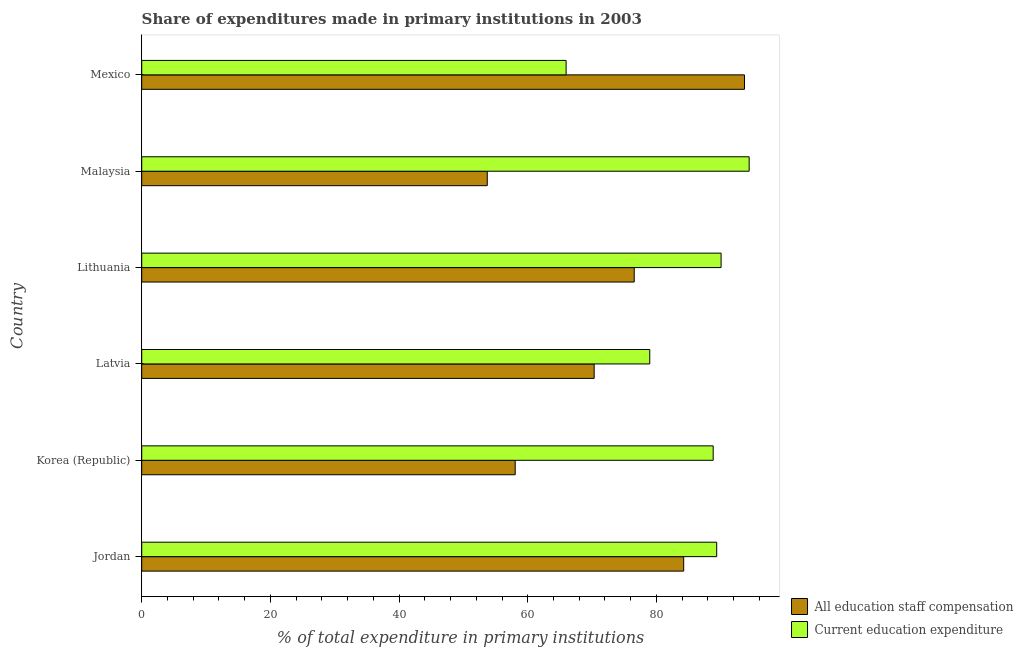How many different coloured bars are there?
Your answer should be very brief. 2. How many groups of bars are there?
Your response must be concise. 6. Are the number of bars per tick equal to the number of legend labels?
Give a very brief answer. Yes. Are the number of bars on each tick of the Y-axis equal?
Keep it short and to the point. Yes. How many bars are there on the 6th tick from the bottom?
Provide a succinct answer. 2. What is the label of the 5th group of bars from the top?
Make the answer very short. Korea (Republic). What is the expenditure in education in Jordan?
Your answer should be compact. 89.37. Across all countries, what is the maximum expenditure in staff compensation?
Ensure brevity in your answer.  93.68. Across all countries, what is the minimum expenditure in staff compensation?
Offer a very short reply. 53.71. In which country was the expenditure in education minimum?
Ensure brevity in your answer.  Mexico. What is the total expenditure in staff compensation in the graph?
Ensure brevity in your answer.  436.54. What is the difference between the expenditure in education in Jordan and that in Mexico?
Your response must be concise. 23.41. What is the difference between the expenditure in education in Mexico and the expenditure in staff compensation in Korea (Republic)?
Provide a short and direct response. 7.91. What is the average expenditure in education per country?
Ensure brevity in your answer.  84.6. What is the difference between the expenditure in staff compensation and expenditure in education in Mexico?
Provide a succinct answer. 27.72. What is the ratio of the expenditure in education in Jordan to that in Latvia?
Make the answer very short. 1.13. Is the expenditure in staff compensation in Jordan less than that in Lithuania?
Your answer should be compact. No. What is the difference between the highest and the second highest expenditure in education?
Provide a short and direct response. 4.36. What is the difference between the highest and the lowest expenditure in education?
Offer a terse response. 28.45. Is the sum of the expenditure in education in Korea (Republic) and Lithuania greater than the maximum expenditure in staff compensation across all countries?
Ensure brevity in your answer.  Yes. What does the 1st bar from the top in Lithuania represents?
Ensure brevity in your answer.  Current education expenditure. What does the 2nd bar from the bottom in Malaysia represents?
Keep it short and to the point. Current education expenditure. How many bars are there?
Ensure brevity in your answer.  12. Are all the bars in the graph horizontal?
Provide a short and direct response. Yes. How many countries are there in the graph?
Make the answer very short. 6. What is the difference between two consecutive major ticks on the X-axis?
Provide a short and direct response. 20. Are the values on the major ticks of X-axis written in scientific E-notation?
Offer a terse response. No. Does the graph contain any zero values?
Keep it short and to the point. No. Does the graph contain grids?
Your answer should be very brief. No. Where does the legend appear in the graph?
Your answer should be very brief. Bottom right. How many legend labels are there?
Keep it short and to the point. 2. How are the legend labels stacked?
Make the answer very short. Vertical. What is the title of the graph?
Keep it short and to the point. Share of expenditures made in primary institutions in 2003. What is the label or title of the X-axis?
Your answer should be very brief. % of total expenditure in primary institutions. What is the % of total expenditure in primary institutions in All education staff compensation in Jordan?
Your answer should be compact. 84.24. What is the % of total expenditure in primary institutions in Current education expenditure in Jordan?
Make the answer very short. 89.37. What is the % of total expenditure in primary institutions of All education staff compensation in Korea (Republic)?
Your answer should be compact. 58.05. What is the % of total expenditure in primary institutions in Current education expenditure in Korea (Republic)?
Your response must be concise. 88.82. What is the % of total expenditure in primary institutions of All education staff compensation in Latvia?
Offer a terse response. 70.32. What is the % of total expenditure in primary institutions of Current education expenditure in Latvia?
Offer a terse response. 78.96. What is the % of total expenditure in primary institutions of All education staff compensation in Lithuania?
Keep it short and to the point. 76.55. What is the % of total expenditure in primary institutions in Current education expenditure in Lithuania?
Give a very brief answer. 90.05. What is the % of total expenditure in primary institutions in All education staff compensation in Malaysia?
Your response must be concise. 53.71. What is the % of total expenditure in primary institutions of Current education expenditure in Malaysia?
Make the answer very short. 94.41. What is the % of total expenditure in primary institutions in All education staff compensation in Mexico?
Provide a succinct answer. 93.68. What is the % of total expenditure in primary institutions of Current education expenditure in Mexico?
Keep it short and to the point. 65.96. Across all countries, what is the maximum % of total expenditure in primary institutions in All education staff compensation?
Offer a terse response. 93.68. Across all countries, what is the maximum % of total expenditure in primary institutions in Current education expenditure?
Your response must be concise. 94.41. Across all countries, what is the minimum % of total expenditure in primary institutions in All education staff compensation?
Keep it short and to the point. 53.71. Across all countries, what is the minimum % of total expenditure in primary institutions of Current education expenditure?
Provide a short and direct response. 65.96. What is the total % of total expenditure in primary institutions in All education staff compensation in the graph?
Provide a short and direct response. 436.54. What is the total % of total expenditure in primary institutions of Current education expenditure in the graph?
Provide a short and direct response. 507.57. What is the difference between the % of total expenditure in primary institutions in All education staff compensation in Jordan and that in Korea (Republic)?
Your response must be concise. 26.19. What is the difference between the % of total expenditure in primary institutions of Current education expenditure in Jordan and that in Korea (Republic)?
Offer a terse response. 0.55. What is the difference between the % of total expenditure in primary institutions of All education staff compensation in Jordan and that in Latvia?
Give a very brief answer. 13.92. What is the difference between the % of total expenditure in primary institutions in Current education expenditure in Jordan and that in Latvia?
Your response must be concise. 10.41. What is the difference between the % of total expenditure in primary institutions of All education staff compensation in Jordan and that in Lithuania?
Your response must be concise. 7.69. What is the difference between the % of total expenditure in primary institutions of Current education expenditure in Jordan and that in Lithuania?
Keep it short and to the point. -0.68. What is the difference between the % of total expenditure in primary institutions in All education staff compensation in Jordan and that in Malaysia?
Give a very brief answer. 30.53. What is the difference between the % of total expenditure in primary institutions of Current education expenditure in Jordan and that in Malaysia?
Make the answer very short. -5.04. What is the difference between the % of total expenditure in primary institutions in All education staff compensation in Jordan and that in Mexico?
Ensure brevity in your answer.  -9.45. What is the difference between the % of total expenditure in primary institutions of Current education expenditure in Jordan and that in Mexico?
Offer a very short reply. 23.41. What is the difference between the % of total expenditure in primary institutions in All education staff compensation in Korea (Republic) and that in Latvia?
Your response must be concise. -12.27. What is the difference between the % of total expenditure in primary institutions of Current education expenditure in Korea (Republic) and that in Latvia?
Offer a terse response. 9.86. What is the difference between the % of total expenditure in primary institutions in All education staff compensation in Korea (Republic) and that in Lithuania?
Keep it short and to the point. -18.5. What is the difference between the % of total expenditure in primary institutions in Current education expenditure in Korea (Republic) and that in Lithuania?
Your answer should be compact. -1.23. What is the difference between the % of total expenditure in primary institutions of All education staff compensation in Korea (Republic) and that in Malaysia?
Offer a terse response. 4.34. What is the difference between the % of total expenditure in primary institutions of Current education expenditure in Korea (Republic) and that in Malaysia?
Provide a short and direct response. -5.59. What is the difference between the % of total expenditure in primary institutions of All education staff compensation in Korea (Republic) and that in Mexico?
Give a very brief answer. -35.64. What is the difference between the % of total expenditure in primary institutions in Current education expenditure in Korea (Republic) and that in Mexico?
Provide a short and direct response. 22.86. What is the difference between the % of total expenditure in primary institutions of All education staff compensation in Latvia and that in Lithuania?
Offer a very short reply. -6.23. What is the difference between the % of total expenditure in primary institutions in Current education expenditure in Latvia and that in Lithuania?
Keep it short and to the point. -11.09. What is the difference between the % of total expenditure in primary institutions of All education staff compensation in Latvia and that in Malaysia?
Offer a terse response. 16.61. What is the difference between the % of total expenditure in primary institutions of Current education expenditure in Latvia and that in Malaysia?
Make the answer very short. -15.45. What is the difference between the % of total expenditure in primary institutions of All education staff compensation in Latvia and that in Mexico?
Provide a short and direct response. -23.36. What is the difference between the % of total expenditure in primary institutions in Current education expenditure in Latvia and that in Mexico?
Give a very brief answer. 13. What is the difference between the % of total expenditure in primary institutions in All education staff compensation in Lithuania and that in Malaysia?
Provide a succinct answer. 22.84. What is the difference between the % of total expenditure in primary institutions in Current education expenditure in Lithuania and that in Malaysia?
Provide a succinct answer. -4.36. What is the difference between the % of total expenditure in primary institutions of All education staff compensation in Lithuania and that in Mexico?
Make the answer very short. -17.14. What is the difference between the % of total expenditure in primary institutions of Current education expenditure in Lithuania and that in Mexico?
Ensure brevity in your answer.  24.09. What is the difference between the % of total expenditure in primary institutions of All education staff compensation in Malaysia and that in Mexico?
Ensure brevity in your answer.  -39.98. What is the difference between the % of total expenditure in primary institutions in Current education expenditure in Malaysia and that in Mexico?
Give a very brief answer. 28.45. What is the difference between the % of total expenditure in primary institutions of All education staff compensation in Jordan and the % of total expenditure in primary institutions of Current education expenditure in Korea (Republic)?
Offer a very short reply. -4.58. What is the difference between the % of total expenditure in primary institutions of All education staff compensation in Jordan and the % of total expenditure in primary institutions of Current education expenditure in Latvia?
Your answer should be compact. 5.28. What is the difference between the % of total expenditure in primary institutions of All education staff compensation in Jordan and the % of total expenditure in primary institutions of Current education expenditure in Lithuania?
Give a very brief answer. -5.81. What is the difference between the % of total expenditure in primary institutions in All education staff compensation in Jordan and the % of total expenditure in primary institutions in Current education expenditure in Malaysia?
Your response must be concise. -10.17. What is the difference between the % of total expenditure in primary institutions of All education staff compensation in Jordan and the % of total expenditure in primary institutions of Current education expenditure in Mexico?
Your answer should be compact. 18.27. What is the difference between the % of total expenditure in primary institutions of All education staff compensation in Korea (Republic) and the % of total expenditure in primary institutions of Current education expenditure in Latvia?
Keep it short and to the point. -20.91. What is the difference between the % of total expenditure in primary institutions of All education staff compensation in Korea (Republic) and the % of total expenditure in primary institutions of Current education expenditure in Lithuania?
Offer a very short reply. -32. What is the difference between the % of total expenditure in primary institutions of All education staff compensation in Korea (Republic) and the % of total expenditure in primary institutions of Current education expenditure in Malaysia?
Give a very brief answer. -36.36. What is the difference between the % of total expenditure in primary institutions of All education staff compensation in Korea (Republic) and the % of total expenditure in primary institutions of Current education expenditure in Mexico?
Ensure brevity in your answer.  -7.91. What is the difference between the % of total expenditure in primary institutions of All education staff compensation in Latvia and the % of total expenditure in primary institutions of Current education expenditure in Lithuania?
Offer a terse response. -19.73. What is the difference between the % of total expenditure in primary institutions in All education staff compensation in Latvia and the % of total expenditure in primary institutions in Current education expenditure in Malaysia?
Offer a terse response. -24.09. What is the difference between the % of total expenditure in primary institutions in All education staff compensation in Latvia and the % of total expenditure in primary institutions in Current education expenditure in Mexico?
Your answer should be very brief. 4.36. What is the difference between the % of total expenditure in primary institutions of All education staff compensation in Lithuania and the % of total expenditure in primary institutions of Current education expenditure in Malaysia?
Offer a very short reply. -17.86. What is the difference between the % of total expenditure in primary institutions of All education staff compensation in Lithuania and the % of total expenditure in primary institutions of Current education expenditure in Mexico?
Make the answer very short. 10.58. What is the difference between the % of total expenditure in primary institutions in All education staff compensation in Malaysia and the % of total expenditure in primary institutions in Current education expenditure in Mexico?
Your response must be concise. -12.26. What is the average % of total expenditure in primary institutions in All education staff compensation per country?
Ensure brevity in your answer.  72.76. What is the average % of total expenditure in primary institutions in Current education expenditure per country?
Offer a terse response. 84.6. What is the difference between the % of total expenditure in primary institutions in All education staff compensation and % of total expenditure in primary institutions in Current education expenditure in Jordan?
Your answer should be very brief. -5.13. What is the difference between the % of total expenditure in primary institutions of All education staff compensation and % of total expenditure in primary institutions of Current education expenditure in Korea (Republic)?
Your answer should be compact. -30.77. What is the difference between the % of total expenditure in primary institutions in All education staff compensation and % of total expenditure in primary institutions in Current education expenditure in Latvia?
Ensure brevity in your answer.  -8.64. What is the difference between the % of total expenditure in primary institutions of All education staff compensation and % of total expenditure in primary institutions of Current education expenditure in Lithuania?
Make the answer very short. -13.5. What is the difference between the % of total expenditure in primary institutions in All education staff compensation and % of total expenditure in primary institutions in Current education expenditure in Malaysia?
Ensure brevity in your answer.  -40.7. What is the difference between the % of total expenditure in primary institutions in All education staff compensation and % of total expenditure in primary institutions in Current education expenditure in Mexico?
Make the answer very short. 27.72. What is the ratio of the % of total expenditure in primary institutions in All education staff compensation in Jordan to that in Korea (Republic)?
Keep it short and to the point. 1.45. What is the ratio of the % of total expenditure in primary institutions of All education staff compensation in Jordan to that in Latvia?
Your answer should be compact. 1.2. What is the ratio of the % of total expenditure in primary institutions of Current education expenditure in Jordan to that in Latvia?
Give a very brief answer. 1.13. What is the ratio of the % of total expenditure in primary institutions in All education staff compensation in Jordan to that in Lithuania?
Offer a terse response. 1.1. What is the ratio of the % of total expenditure in primary institutions of Current education expenditure in Jordan to that in Lithuania?
Your answer should be very brief. 0.99. What is the ratio of the % of total expenditure in primary institutions of All education staff compensation in Jordan to that in Malaysia?
Provide a succinct answer. 1.57. What is the ratio of the % of total expenditure in primary institutions in Current education expenditure in Jordan to that in Malaysia?
Make the answer very short. 0.95. What is the ratio of the % of total expenditure in primary institutions in All education staff compensation in Jordan to that in Mexico?
Ensure brevity in your answer.  0.9. What is the ratio of the % of total expenditure in primary institutions of Current education expenditure in Jordan to that in Mexico?
Provide a short and direct response. 1.35. What is the ratio of the % of total expenditure in primary institutions in All education staff compensation in Korea (Republic) to that in Latvia?
Offer a terse response. 0.83. What is the ratio of the % of total expenditure in primary institutions in Current education expenditure in Korea (Republic) to that in Latvia?
Ensure brevity in your answer.  1.12. What is the ratio of the % of total expenditure in primary institutions in All education staff compensation in Korea (Republic) to that in Lithuania?
Ensure brevity in your answer.  0.76. What is the ratio of the % of total expenditure in primary institutions of Current education expenditure in Korea (Republic) to that in Lithuania?
Ensure brevity in your answer.  0.99. What is the ratio of the % of total expenditure in primary institutions of All education staff compensation in Korea (Republic) to that in Malaysia?
Make the answer very short. 1.08. What is the ratio of the % of total expenditure in primary institutions in Current education expenditure in Korea (Republic) to that in Malaysia?
Your answer should be very brief. 0.94. What is the ratio of the % of total expenditure in primary institutions of All education staff compensation in Korea (Republic) to that in Mexico?
Your answer should be compact. 0.62. What is the ratio of the % of total expenditure in primary institutions in Current education expenditure in Korea (Republic) to that in Mexico?
Ensure brevity in your answer.  1.35. What is the ratio of the % of total expenditure in primary institutions of All education staff compensation in Latvia to that in Lithuania?
Offer a terse response. 0.92. What is the ratio of the % of total expenditure in primary institutions in Current education expenditure in Latvia to that in Lithuania?
Ensure brevity in your answer.  0.88. What is the ratio of the % of total expenditure in primary institutions in All education staff compensation in Latvia to that in Malaysia?
Provide a short and direct response. 1.31. What is the ratio of the % of total expenditure in primary institutions of Current education expenditure in Latvia to that in Malaysia?
Your response must be concise. 0.84. What is the ratio of the % of total expenditure in primary institutions of All education staff compensation in Latvia to that in Mexico?
Your answer should be very brief. 0.75. What is the ratio of the % of total expenditure in primary institutions in Current education expenditure in Latvia to that in Mexico?
Make the answer very short. 1.2. What is the ratio of the % of total expenditure in primary institutions of All education staff compensation in Lithuania to that in Malaysia?
Make the answer very short. 1.43. What is the ratio of the % of total expenditure in primary institutions in Current education expenditure in Lithuania to that in Malaysia?
Your answer should be very brief. 0.95. What is the ratio of the % of total expenditure in primary institutions of All education staff compensation in Lithuania to that in Mexico?
Offer a terse response. 0.82. What is the ratio of the % of total expenditure in primary institutions of Current education expenditure in Lithuania to that in Mexico?
Offer a very short reply. 1.37. What is the ratio of the % of total expenditure in primary institutions of All education staff compensation in Malaysia to that in Mexico?
Keep it short and to the point. 0.57. What is the ratio of the % of total expenditure in primary institutions in Current education expenditure in Malaysia to that in Mexico?
Your response must be concise. 1.43. What is the difference between the highest and the second highest % of total expenditure in primary institutions in All education staff compensation?
Your answer should be very brief. 9.45. What is the difference between the highest and the second highest % of total expenditure in primary institutions in Current education expenditure?
Your answer should be compact. 4.36. What is the difference between the highest and the lowest % of total expenditure in primary institutions of All education staff compensation?
Provide a succinct answer. 39.98. What is the difference between the highest and the lowest % of total expenditure in primary institutions in Current education expenditure?
Keep it short and to the point. 28.45. 